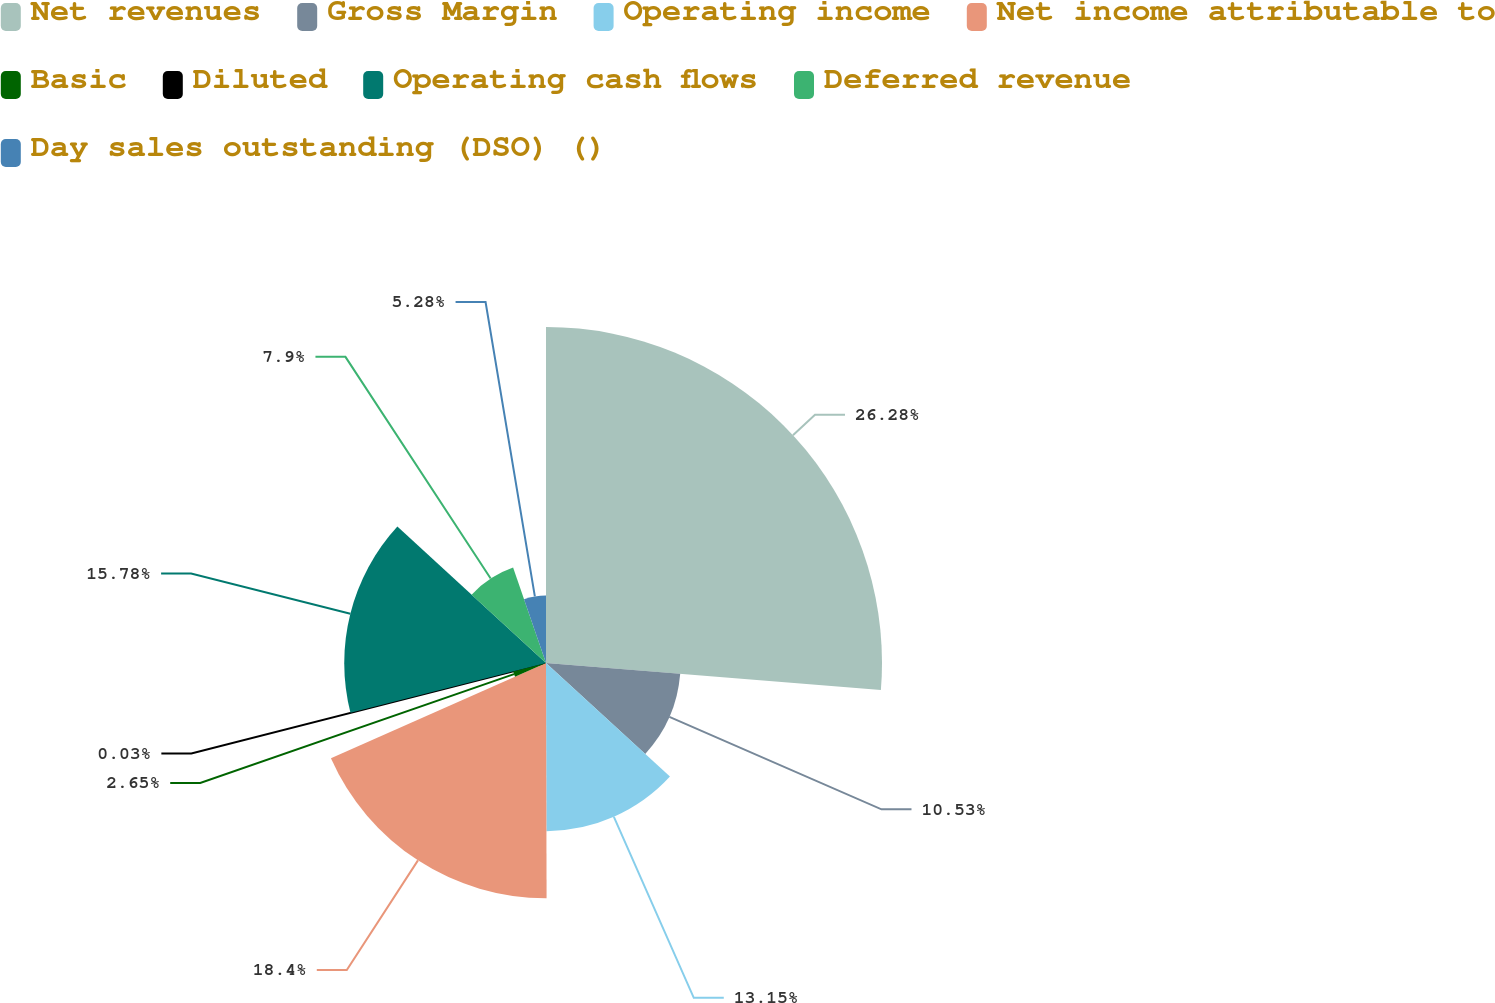Convert chart. <chart><loc_0><loc_0><loc_500><loc_500><pie_chart><fcel>Net revenues<fcel>Gross Margin<fcel>Operating income<fcel>Net income attributable to<fcel>Basic<fcel>Diluted<fcel>Operating cash flows<fcel>Deferred revenue<fcel>Day sales outstanding (DSO) ()<nl><fcel>26.28%<fcel>10.53%<fcel>13.15%<fcel>18.4%<fcel>2.65%<fcel>0.03%<fcel>15.78%<fcel>7.9%<fcel>5.28%<nl></chart> 